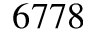Convert formula to latex. <formula><loc_0><loc_0><loc_500><loc_500>6 7 7 8</formula> 